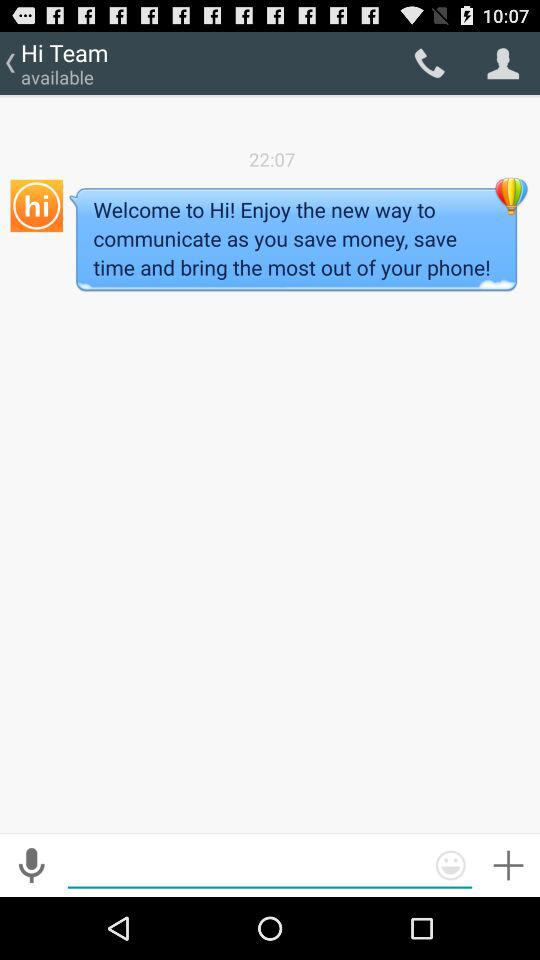What is the status of the "Hi team"? The status is "available". 